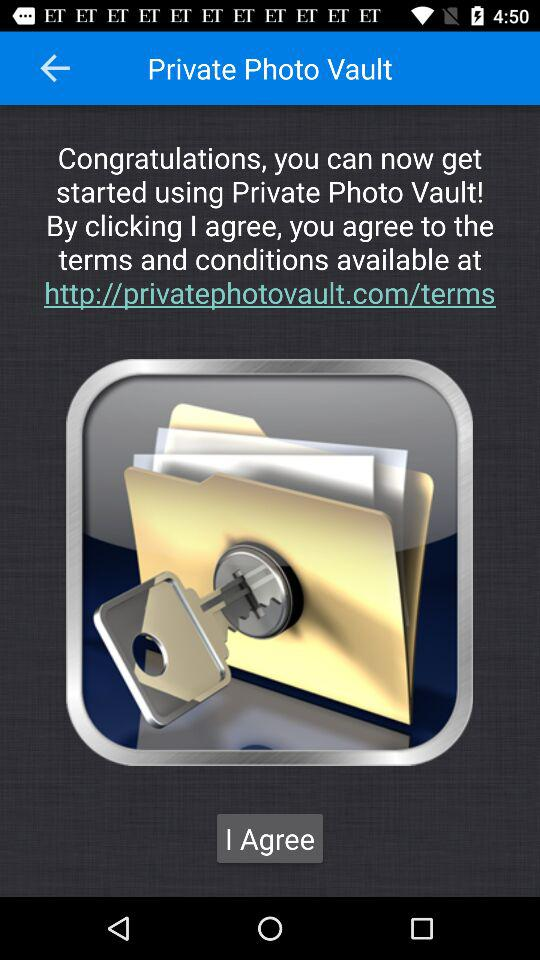What is the application name? The application name is "Private Photo Vault". 